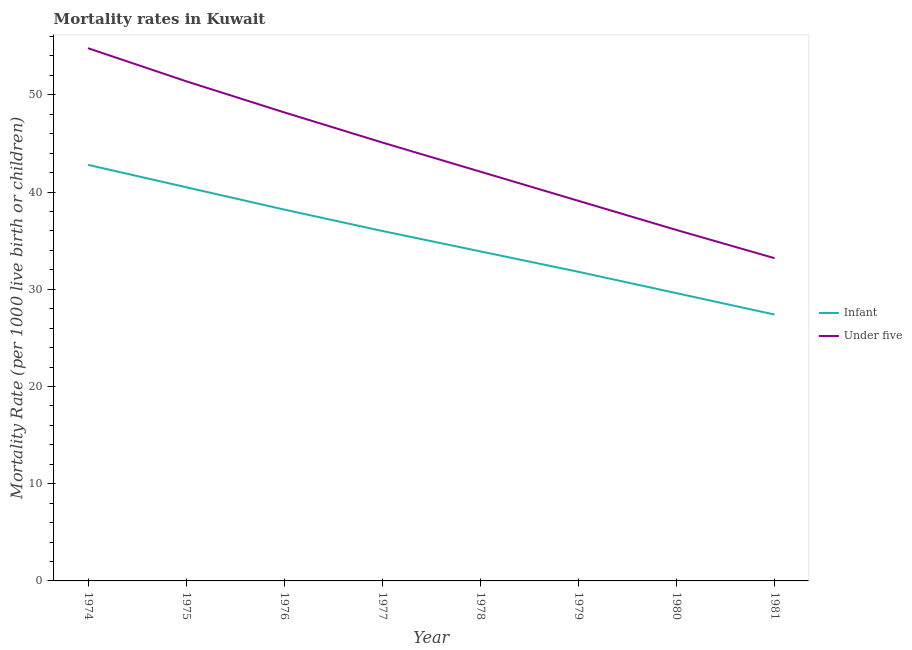How many different coloured lines are there?
Provide a short and direct response. 2. Does the line corresponding to under-5 mortality rate intersect with the line corresponding to infant mortality rate?
Make the answer very short. No. What is the under-5 mortality rate in 1975?
Make the answer very short. 51.4. Across all years, what is the maximum under-5 mortality rate?
Ensure brevity in your answer.  54.8. Across all years, what is the minimum under-5 mortality rate?
Provide a succinct answer. 33.2. In which year was the infant mortality rate maximum?
Provide a short and direct response. 1974. In which year was the under-5 mortality rate minimum?
Give a very brief answer. 1981. What is the total infant mortality rate in the graph?
Offer a very short reply. 280.2. What is the difference between the under-5 mortality rate in 1977 and that in 1981?
Give a very brief answer. 11.9. What is the difference between the under-5 mortality rate in 1976 and the infant mortality rate in 1978?
Your response must be concise. 14.3. What is the average infant mortality rate per year?
Offer a terse response. 35.02. In how many years, is the infant mortality rate greater than 44?
Give a very brief answer. 0. What is the ratio of the under-5 mortality rate in 1979 to that in 1981?
Your answer should be compact. 1.18. What is the difference between the highest and the second highest under-5 mortality rate?
Make the answer very short. 3.4. What is the difference between the highest and the lowest under-5 mortality rate?
Offer a terse response. 21.6. In how many years, is the under-5 mortality rate greater than the average under-5 mortality rate taken over all years?
Offer a terse response. 4. Is the infant mortality rate strictly less than the under-5 mortality rate over the years?
Offer a very short reply. Yes. How many years are there in the graph?
Give a very brief answer. 8. How many legend labels are there?
Make the answer very short. 2. How are the legend labels stacked?
Your answer should be very brief. Vertical. What is the title of the graph?
Offer a terse response. Mortality rates in Kuwait. What is the label or title of the X-axis?
Your answer should be very brief. Year. What is the label or title of the Y-axis?
Keep it short and to the point. Mortality Rate (per 1000 live birth or children). What is the Mortality Rate (per 1000 live birth or children) of Infant in 1974?
Provide a succinct answer. 42.8. What is the Mortality Rate (per 1000 live birth or children) of Under five in 1974?
Offer a terse response. 54.8. What is the Mortality Rate (per 1000 live birth or children) in Infant in 1975?
Your answer should be very brief. 40.5. What is the Mortality Rate (per 1000 live birth or children) of Under five in 1975?
Offer a very short reply. 51.4. What is the Mortality Rate (per 1000 live birth or children) of Infant in 1976?
Offer a terse response. 38.2. What is the Mortality Rate (per 1000 live birth or children) in Under five in 1976?
Offer a terse response. 48.2. What is the Mortality Rate (per 1000 live birth or children) in Infant in 1977?
Make the answer very short. 36. What is the Mortality Rate (per 1000 live birth or children) in Under five in 1977?
Offer a terse response. 45.1. What is the Mortality Rate (per 1000 live birth or children) in Infant in 1978?
Give a very brief answer. 33.9. What is the Mortality Rate (per 1000 live birth or children) in Under five in 1978?
Offer a terse response. 42.1. What is the Mortality Rate (per 1000 live birth or children) in Infant in 1979?
Offer a terse response. 31.8. What is the Mortality Rate (per 1000 live birth or children) in Under five in 1979?
Give a very brief answer. 39.1. What is the Mortality Rate (per 1000 live birth or children) of Infant in 1980?
Your answer should be very brief. 29.6. What is the Mortality Rate (per 1000 live birth or children) of Under five in 1980?
Make the answer very short. 36.1. What is the Mortality Rate (per 1000 live birth or children) of Infant in 1981?
Keep it short and to the point. 27.4. What is the Mortality Rate (per 1000 live birth or children) in Under five in 1981?
Offer a terse response. 33.2. Across all years, what is the maximum Mortality Rate (per 1000 live birth or children) in Infant?
Offer a terse response. 42.8. Across all years, what is the maximum Mortality Rate (per 1000 live birth or children) in Under five?
Your response must be concise. 54.8. Across all years, what is the minimum Mortality Rate (per 1000 live birth or children) in Infant?
Provide a short and direct response. 27.4. Across all years, what is the minimum Mortality Rate (per 1000 live birth or children) in Under five?
Offer a terse response. 33.2. What is the total Mortality Rate (per 1000 live birth or children) of Infant in the graph?
Your response must be concise. 280.2. What is the total Mortality Rate (per 1000 live birth or children) of Under five in the graph?
Your answer should be compact. 350. What is the difference between the Mortality Rate (per 1000 live birth or children) of Infant in 1974 and that in 1975?
Your answer should be very brief. 2.3. What is the difference between the Mortality Rate (per 1000 live birth or children) in Under five in 1974 and that in 1975?
Offer a terse response. 3.4. What is the difference between the Mortality Rate (per 1000 live birth or children) of Infant in 1974 and that in 1976?
Ensure brevity in your answer.  4.6. What is the difference between the Mortality Rate (per 1000 live birth or children) in Infant in 1974 and that in 1977?
Your answer should be compact. 6.8. What is the difference between the Mortality Rate (per 1000 live birth or children) of Under five in 1974 and that in 1977?
Your answer should be compact. 9.7. What is the difference between the Mortality Rate (per 1000 live birth or children) in Under five in 1974 and that in 1978?
Keep it short and to the point. 12.7. What is the difference between the Mortality Rate (per 1000 live birth or children) in Under five in 1974 and that in 1979?
Make the answer very short. 15.7. What is the difference between the Mortality Rate (per 1000 live birth or children) in Infant in 1974 and that in 1980?
Your answer should be very brief. 13.2. What is the difference between the Mortality Rate (per 1000 live birth or children) in Under five in 1974 and that in 1980?
Offer a very short reply. 18.7. What is the difference between the Mortality Rate (per 1000 live birth or children) of Under five in 1974 and that in 1981?
Offer a terse response. 21.6. What is the difference between the Mortality Rate (per 1000 live birth or children) of Infant in 1975 and that in 1976?
Offer a terse response. 2.3. What is the difference between the Mortality Rate (per 1000 live birth or children) of Under five in 1975 and that in 1976?
Provide a succinct answer. 3.2. What is the difference between the Mortality Rate (per 1000 live birth or children) of Infant in 1975 and that in 1977?
Your answer should be compact. 4.5. What is the difference between the Mortality Rate (per 1000 live birth or children) of Under five in 1975 and that in 1977?
Your response must be concise. 6.3. What is the difference between the Mortality Rate (per 1000 live birth or children) of Under five in 1975 and that in 1978?
Give a very brief answer. 9.3. What is the difference between the Mortality Rate (per 1000 live birth or children) in Infant in 1975 and that in 1980?
Provide a succinct answer. 10.9. What is the difference between the Mortality Rate (per 1000 live birth or children) in Under five in 1975 and that in 1980?
Provide a short and direct response. 15.3. What is the difference between the Mortality Rate (per 1000 live birth or children) of Infant in 1975 and that in 1981?
Your answer should be very brief. 13.1. What is the difference between the Mortality Rate (per 1000 live birth or children) in Under five in 1975 and that in 1981?
Provide a succinct answer. 18.2. What is the difference between the Mortality Rate (per 1000 live birth or children) in Infant in 1976 and that in 1977?
Offer a terse response. 2.2. What is the difference between the Mortality Rate (per 1000 live birth or children) of Infant in 1976 and that in 1978?
Your answer should be very brief. 4.3. What is the difference between the Mortality Rate (per 1000 live birth or children) in Under five in 1976 and that in 1978?
Keep it short and to the point. 6.1. What is the difference between the Mortality Rate (per 1000 live birth or children) in Infant in 1976 and that in 1979?
Provide a succinct answer. 6.4. What is the difference between the Mortality Rate (per 1000 live birth or children) in Under five in 1976 and that in 1980?
Offer a terse response. 12.1. What is the difference between the Mortality Rate (per 1000 live birth or children) in Under five in 1976 and that in 1981?
Your answer should be compact. 15. What is the difference between the Mortality Rate (per 1000 live birth or children) in Under five in 1977 and that in 1978?
Your response must be concise. 3. What is the difference between the Mortality Rate (per 1000 live birth or children) in Under five in 1977 and that in 1980?
Make the answer very short. 9. What is the difference between the Mortality Rate (per 1000 live birth or children) of Infant in 1977 and that in 1981?
Ensure brevity in your answer.  8.6. What is the difference between the Mortality Rate (per 1000 live birth or children) of Under five in 1977 and that in 1981?
Your answer should be compact. 11.9. What is the difference between the Mortality Rate (per 1000 live birth or children) in Infant in 1978 and that in 1979?
Offer a very short reply. 2.1. What is the difference between the Mortality Rate (per 1000 live birth or children) of Under five in 1978 and that in 1979?
Your answer should be very brief. 3. What is the difference between the Mortality Rate (per 1000 live birth or children) of Infant in 1978 and that in 1981?
Provide a succinct answer. 6.5. What is the difference between the Mortality Rate (per 1000 live birth or children) in Under five in 1978 and that in 1981?
Your response must be concise. 8.9. What is the difference between the Mortality Rate (per 1000 live birth or children) of Infant in 1979 and that in 1980?
Ensure brevity in your answer.  2.2. What is the difference between the Mortality Rate (per 1000 live birth or children) of Infant in 1979 and that in 1981?
Your answer should be compact. 4.4. What is the difference between the Mortality Rate (per 1000 live birth or children) of Under five in 1979 and that in 1981?
Offer a very short reply. 5.9. What is the difference between the Mortality Rate (per 1000 live birth or children) of Infant in 1974 and the Mortality Rate (per 1000 live birth or children) of Under five in 1976?
Provide a short and direct response. -5.4. What is the difference between the Mortality Rate (per 1000 live birth or children) in Infant in 1974 and the Mortality Rate (per 1000 live birth or children) in Under five in 1980?
Keep it short and to the point. 6.7. What is the difference between the Mortality Rate (per 1000 live birth or children) in Infant in 1975 and the Mortality Rate (per 1000 live birth or children) in Under five in 1978?
Ensure brevity in your answer.  -1.6. What is the difference between the Mortality Rate (per 1000 live birth or children) of Infant in 1976 and the Mortality Rate (per 1000 live birth or children) of Under five in 1977?
Your answer should be compact. -6.9. What is the difference between the Mortality Rate (per 1000 live birth or children) in Infant in 1976 and the Mortality Rate (per 1000 live birth or children) in Under five in 1978?
Give a very brief answer. -3.9. What is the difference between the Mortality Rate (per 1000 live birth or children) of Infant in 1976 and the Mortality Rate (per 1000 live birth or children) of Under five in 1979?
Ensure brevity in your answer.  -0.9. What is the difference between the Mortality Rate (per 1000 live birth or children) of Infant in 1977 and the Mortality Rate (per 1000 live birth or children) of Under five in 1980?
Give a very brief answer. -0.1. What is the difference between the Mortality Rate (per 1000 live birth or children) of Infant in 1977 and the Mortality Rate (per 1000 live birth or children) of Under five in 1981?
Give a very brief answer. 2.8. What is the difference between the Mortality Rate (per 1000 live birth or children) of Infant in 1978 and the Mortality Rate (per 1000 live birth or children) of Under five in 1979?
Provide a short and direct response. -5.2. What is the difference between the Mortality Rate (per 1000 live birth or children) of Infant in 1978 and the Mortality Rate (per 1000 live birth or children) of Under five in 1980?
Make the answer very short. -2.2. What is the difference between the Mortality Rate (per 1000 live birth or children) in Infant in 1978 and the Mortality Rate (per 1000 live birth or children) in Under five in 1981?
Your answer should be very brief. 0.7. What is the difference between the Mortality Rate (per 1000 live birth or children) of Infant in 1979 and the Mortality Rate (per 1000 live birth or children) of Under five in 1981?
Offer a very short reply. -1.4. What is the difference between the Mortality Rate (per 1000 live birth or children) in Infant in 1980 and the Mortality Rate (per 1000 live birth or children) in Under five in 1981?
Offer a very short reply. -3.6. What is the average Mortality Rate (per 1000 live birth or children) in Infant per year?
Ensure brevity in your answer.  35.02. What is the average Mortality Rate (per 1000 live birth or children) of Under five per year?
Your answer should be compact. 43.75. In the year 1974, what is the difference between the Mortality Rate (per 1000 live birth or children) in Infant and Mortality Rate (per 1000 live birth or children) in Under five?
Give a very brief answer. -12. In the year 1975, what is the difference between the Mortality Rate (per 1000 live birth or children) in Infant and Mortality Rate (per 1000 live birth or children) in Under five?
Your answer should be compact. -10.9. In the year 1976, what is the difference between the Mortality Rate (per 1000 live birth or children) of Infant and Mortality Rate (per 1000 live birth or children) of Under five?
Offer a terse response. -10. In the year 1977, what is the difference between the Mortality Rate (per 1000 live birth or children) in Infant and Mortality Rate (per 1000 live birth or children) in Under five?
Provide a short and direct response. -9.1. In the year 1979, what is the difference between the Mortality Rate (per 1000 live birth or children) of Infant and Mortality Rate (per 1000 live birth or children) of Under five?
Make the answer very short. -7.3. In the year 1980, what is the difference between the Mortality Rate (per 1000 live birth or children) in Infant and Mortality Rate (per 1000 live birth or children) in Under five?
Give a very brief answer. -6.5. What is the ratio of the Mortality Rate (per 1000 live birth or children) of Infant in 1974 to that in 1975?
Keep it short and to the point. 1.06. What is the ratio of the Mortality Rate (per 1000 live birth or children) in Under five in 1974 to that in 1975?
Provide a succinct answer. 1.07. What is the ratio of the Mortality Rate (per 1000 live birth or children) in Infant in 1974 to that in 1976?
Ensure brevity in your answer.  1.12. What is the ratio of the Mortality Rate (per 1000 live birth or children) of Under five in 1974 to that in 1976?
Your response must be concise. 1.14. What is the ratio of the Mortality Rate (per 1000 live birth or children) of Infant in 1974 to that in 1977?
Your response must be concise. 1.19. What is the ratio of the Mortality Rate (per 1000 live birth or children) in Under five in 1974 to that in 1977?
Keep it short and to the point. 1.22. What is the ratio of the Mortality Rate (per 1000 live birth or children) in Infant in 1974 to that in 1978?
Give a very brief answer. 1.26. What is the ratio of the Mortality Rate (per 1000 live birth or children) of Under five in 1974 to that in 1978?
Offer a very short reply. 1.3. What is the ratio of the Mortality Rate (per 1000 live birth or children) of Infant in 1974 to that in 1979?
Keep it short and to the point. 1.35. What is the ratio of the Mortality Rate (per 1000 live birth or children) in Under five in 1974 to that in 1979?
Give a very brief answer. 1.4. What is the ratio of the Mortality Rate (per 1000 live birth or children) of Infant in 1974 to that in 1980?
Your answer should be compact. 1.45. What is the ratio of the Mortality Rate (per 1000 live birth or children) in Under five in 1974 to that in 1980?
Offer a very short reply. 1.52. What is the ratio of the Mortality Rate (per 1000 live birth or children) of Infant in 1974 to that in 1981?
Keep it short and to the point. 1.56. What is the ratio of the Mortality Rate (per 1000 live birth or children) of Under five in 1974 to that in 1981?
Ensure brevity in your answer.  1.65. What is the ratio of the Mortality Rate (per 1000 live birth or children) of Infant in 1975 to that in 1976?
Your answer should be compact. 1.06. What is the ratio of the Mortality Rate (per 1000 live birth or children) in Under five in 1975 to that in 1976?
Provide a succinct answer. 1.07. What is the ratio of the Mortality Rate (per 1000 live birth or children) of Under five in 1975 to that in 1977?
Make the answer very short. 1.14. What is the ratio of the Mortality Rate (per 1000 live birth or children) of Infant in 1975 to that in 1978?
Your answer should be compact. 1.19. What is the ratio of the Mortality Rate (per 1000 live birth or children) of Under five in 1975 to that in 1978?
Offer a very short reply. 1.22. What is the ratio of the Mortality Rate (per 1000 live birth or children) of Infant in 1975 to that in 1979?
Provide a short and direct response. 1.27. What is the ratio of the Mortality Rate (per 1000 live birth or children) in Under five in 1975 to that in 1979?
Give a very brief answer. 1.31. What is the ratio of the Mortality Rate (per 1000 live birth or children) in Infant in 1975 to that in 1980?
Ensure brevity in your answer.  1.37. What is the ratio of the Mortality Rate (per 1000 live birth or children) in Under five in 1975 to that in 1980?
Ensure brevity in your answer.  1.42. What is the ratio of the Mortality Rate (per 1000 live birth or children) in Infant in 1975 to that in 1981?
Your response must be concise. 1.48. What is the ratio of the Mortality Rate (per 1000 live birth or children) of Under five in 1975 to that in 1981?
Give a very brief answer. 1.55. What is the ratio of the Mortality Rate (per 1000 live birth or children) of Infant in 1976 to that in 1977?
Your answer should be very brief. 1.06. What is the ratio of the Mortality Rate (per 1000 live birth or children) in Under five in 1976 to that in 1977?
Give a very brief answer. 1.07. What is the ratio of the Mortality Rate (per 1000 live birth or children) in Infant in 1976 to that in 1978?
Offer a terse response. 1.13. What is the ratio of the Mortality Rate (per 1000 live birth or children) of Under five in 1976 to that in 1978?
Offer a very short reply. 1.14. What is the ratio of the Mortality Rate (per 1000 live birth or children) of Infant in 1976 to that in 1979?
Give a very brief answer. 1.2. What is the ratio of the Mortality Rate (per 1000 live birth or children) in Under five in 1976 to that in 1979?
Provide a short and direct response. 1.23. What is the ratio of the Mortality Rate (per 1000 live birth or children) of Infant in 1976 to that in 1980?
Your answer should be very brief. 1.29. What is the ratio of the Mortality Rate (per 1000 live birth or children) of Under five in 1976 to that in 1980?
Your answer should be compact. 1.34. What is the ratio of the Mortality Rate (per 1000 live birth or children) in Infant in 1976 to that in 1981?
Keep it short and to the point. 1.39. What is the ratio of the Mortality Rate (per 1000 live birth or children) of Under five in 1976 to that in 1981?
Keep it short and to the point. 1.45. What is the ratio of the Mortality Rate (per 1000 live birth or children) in Infant in 1977 to that in 1978?
Your response must be concise. 1.06. What is the ratio of the Mortality Rate (per 1000 live birth or children) of Under five in 1977 to that in 1978?
Give a very brief answer. 1.07. What is the ratio of the Mortality Rate (per 1000 live birth or children) of Infant in 1977 to that in 1979?
Provide a short and direct response. 1.13. What is the ratio of the Mortality Rate (per 1000 live birth or children) of Under five in 1977 to that in 1979?
Provide a succinct answer. 1.15. What is the ratio of the Mortality Rate (per 1000 live birth or children) in Infant in 1977 to that in 1980?
Offer a terse response. 1.22. What is the ratio of the Mortality Rate (per 1000 live birth or children) in Under five in 1977 to that in 1980?
Give a very brief answer. 1.25. What is the ratio of the Mortality Rate (per 1000 live birth or children) of Infant in 1977 to that in 1981?
Provide a short and direct response. 1.31. What is the ratio of the Mortality Rate (per 1000 live birth or children) of Under five in 1977 to that in 1981?
Offer a very short reply. 1.36. What is the ratio of the Mortality Rate (per 1000 live birth or children) of Infant in 1978 to that in 1979?
Make the answer very short. 1.07. What is the ratio of the Mortality Rate (per 1000 live birth or children) in Under five in 1978 to that in 1979?
Provide a succinct answer. 1.08. What is the ratio of the Mortality Rate (per 1000 live birth or children) in Infant in 1978 to that in 1980?
Offer a terse response. 1.15. What is the ratio of the Mortality Rate (per 1000 live birth or children) of Under five in 1978 to that in 1980?
Your response must be concise. 1.17. What is the ratio of the Mortality Rate (per 1000 live birth or children) of Infant in 1978 to that in 1981?
Provide a succinct answer. 1.24. What is the ratio of the Mortality Rate (per 1000 live birth or children) in Under five in 1978 to that in 1981?
Your response must be concise. 1.27. What is the ratio of the Mortality Rate (per 1000 live birth or children) of Infant in 1979 to that in 1980?
Your answer should be compact. 1.07. What is the ratio of the Mortality Rate (per 1000 live birth or children) in Under five in 1979 to that in 1980?
Your response must be concise. 1.08. What is the ratio of the Mortality Rate (per 1000 live birth or children) of Infant in 1979 to that in 1981?
Ensure brevity in your answer.  1.16. What is the ratio of the Mortality Rate (per 1000 live birth or children) in Under five in 1979 to that in 1981?
Provide a succinct answer. 1.18. What is the ratio of the Mortality Rate (per 1000 live birth or children) of Infant in 1980 to that in 1981?
Give a very brief answer. 1.08. What is the ratio of the Mortality Rate (per 1000 live birth or children) in Under five in 1980 to that in 1981?
Ensure brevity in your answer.  1.09. What is the difference between the highest and the lowest Mortality Rate (per 1000 live birth or children) of Infant?
Offer a terse response. 15.4. What is the difference between the highest and the lowest Mortality Rate (per 1000 live birth or children) in Under five?
Your response must be concise. 21.6. 